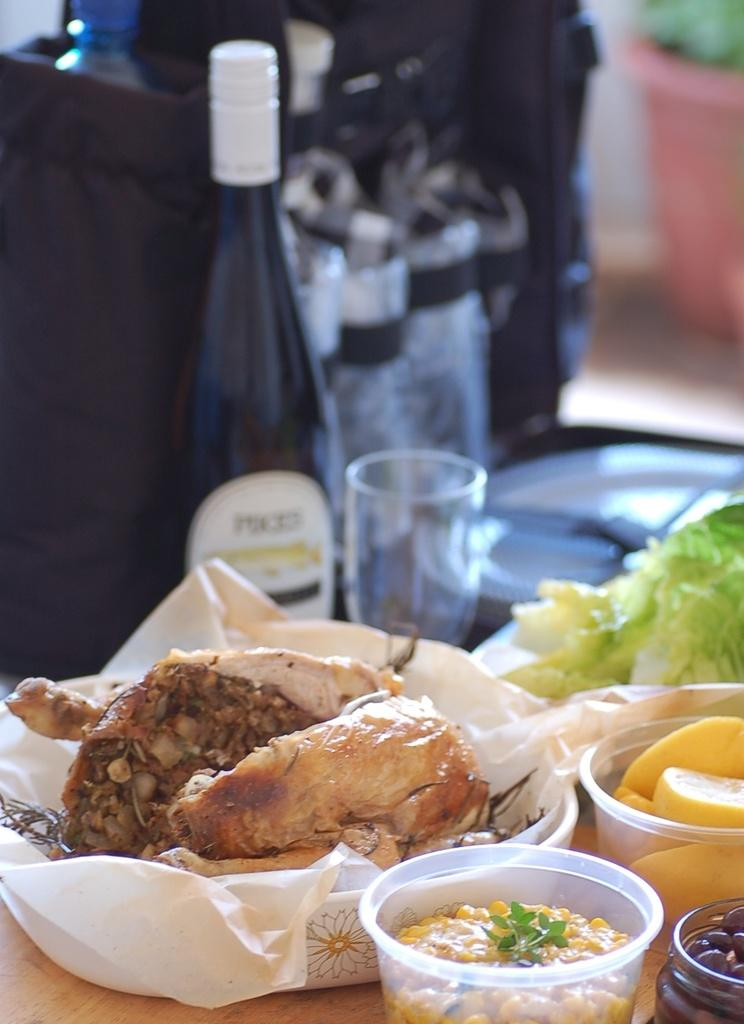What can be found on the table in the image? There is food, a glass, a bottle, and a bowl on the table. What type of container is holding a liquid on the table? There is a glass and a bottle on the table, both of which can hold liquids. What is the purpose of the bowl on the table? The purpose of the bowl on the table is to hold food or other items. What type of beam is supporting the table in the image? There is no beam visible in the image, as it only shows the objects on the table. 